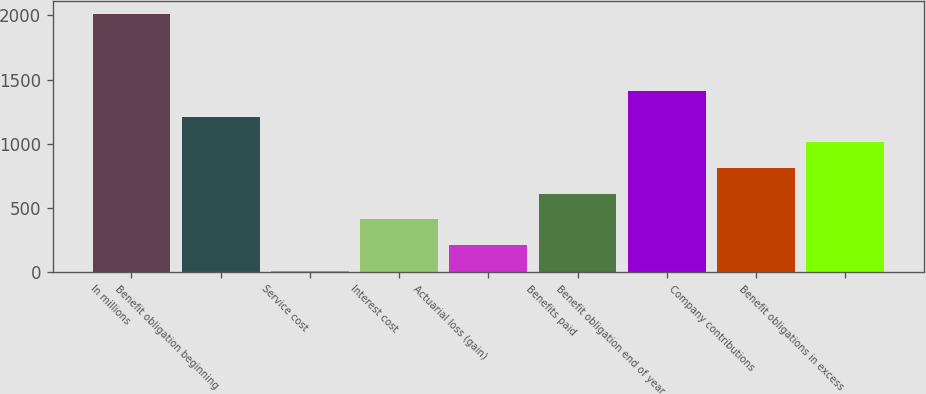Convert chart to OTSL. <chart><loc_0><loc_0><loc_500><loc_500><bar_chart><fcel>In millions<fcel>Benefit obligation beginning<fcel>Service cost<fcel>Interest cost<fcel>Actuarial loss (gain)<fcel>Benefits paid<fcel>Benefit obligation end of year<fcel>Company contributions<fcel>Benefit obligations in excess<nl><fcel>2013<fcel>1211.16<fcel>8.4<fcel>409.32<fcel>208.86<fcel>609.78<fcel>1411.62<fcel>810.24<fcel>1010.7<nl></chart> 